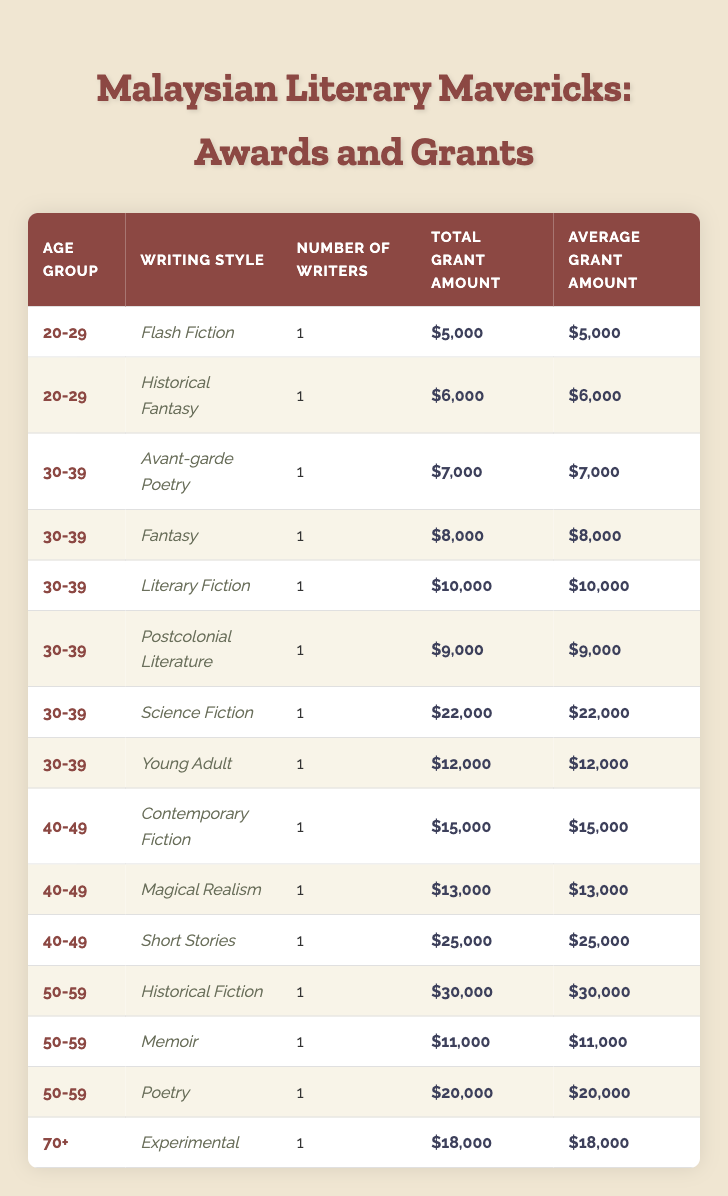What is the total grant amount awarded to writers aged 30-39? From the table, the grant amounts awarded to writers in the age group 30-39 are $7,000 (Avant-garde Poetry), $8,000 (Fantasy), $10,000 (Literary Fiction), $9,000 (Postcolonial Literature), $22,000 (Science Fiction), and $12,000 (Young Adult). Adding these amounts gives: 7000 + 8000 + 10000 + 9000 + 22000 + 12000 = 60000
Answer: 60000 Who received the highest grant amount and what was it? Reviewing the table, the writers and their grant amounts are: Tash Aw ($15,000), Tan Twan Eng ($30,000), Bernice Chauly ($20,000), Shih-Li Kow ($25,000), and other writers with lower amounts. Tan Twan Eng received the highest grant amount of $30,000.
Answer: Tan Twan Eng, $30,000 How many writing styles are represented by writers aged 50-59? In the table, writers aged 50-59 are Tan Twan Eng (Historical Fiction), Saras Manickam (Memoir), and Bernice Chauly (Poetry), which totals three different writing styles: Historical Fiction, Memoir, and Poetry. Therefore, the answer is 3.
Answer: 3 Is there any writer aged 70 or above in the table? The table includes Chuah Guat Eng, who is 78 years old, and is categorized under Experimental writing. Hence, there is indeed a writer aged 70 or above.
Answer: Yes What is the average grant amount for writers aged 40-49? For writers in the 40-49 age group, the grant amounts are $15,000 (Contemporary Fiction), $13,000 (Magical Realism), and $25,000 (Short Stories). The total of these amounts is $15,000 + $13,000 + $25,000 = $53,000. There are 3 writers, so the average grant amount is $53,000 / 3 = $17,666.67.
Answer: 17666.67 Which writing style has the most number of representatives in a single age group, and what is that number? In the 30-39 age group, multiple writing styles are represented: Avant-garde Poetry, Fantasy, Literary Fiction, Postcolonial Literature, Science Fiction, and Young Adult, with each having only 1 representative. Therefore, the maximum number is 1 for each style in this age group.
Answer: 1 What is the total number of writers that have received any awards by the age of 30? The writers under 30 are noted as: Ling Low (29 years) and Joshua Kam (26 years). As there are 2 writers aged 30 and below, the total number of writers under 30 that have received any awards is 2.
Answer: 2 Is the average grant amount for writers aged 20-29 higher than that for writers aged 50-59? The writers aged 20-29 are Joshua Kam ($6,000) and Ling Low ($5,000), giving a total of $11,000 for 2 writers, leading to an average of $11,000 / 2 = $5,500. Writers aged 50-59 received $30,000, $11,000, and $20,000 totaling $61,000 for 3 writers, thus an average of $61,000 / 3 = $20,333.33. Therefore, $5,500 is not higher than $20,333.33.
Answer: No 